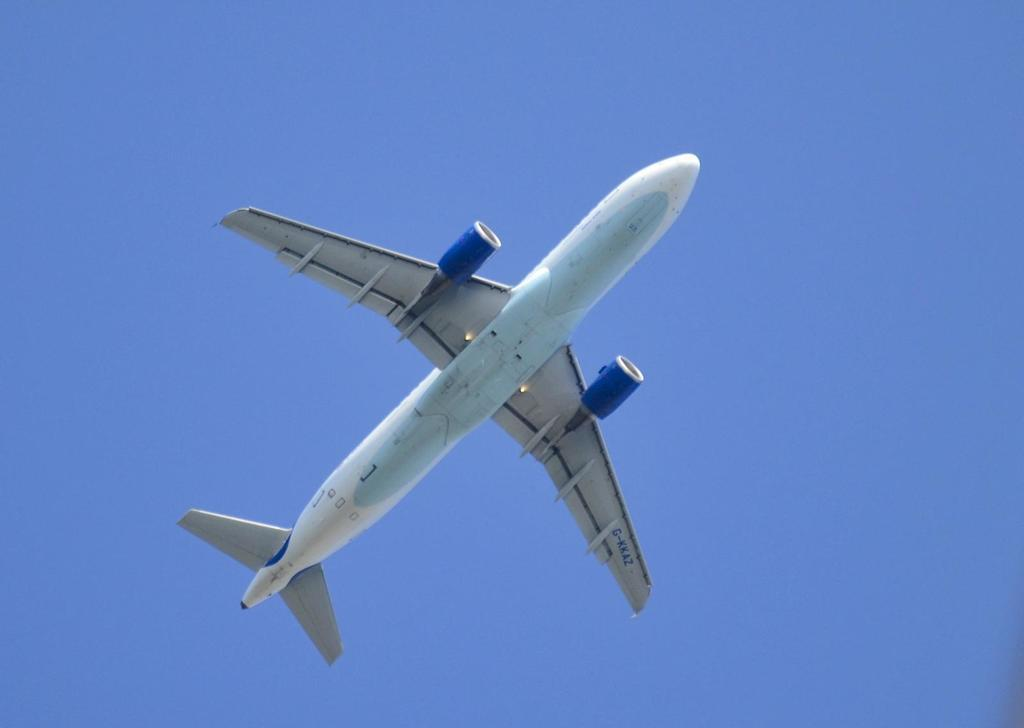What is the main subject of the image? The main subject of the image is an aircraft. What is the aircraft doing in the image? The aircraft is flying in the air. What colors are used to paint the aircraft? The aircraft is in white and blue color. What color is the background of the image? The background of the image is in blue color. How many holes can be seen on the aircraft's legs in the image? There are no holes or legs present on the aircraft in the image, as it is an aircraft and not a living creature. 